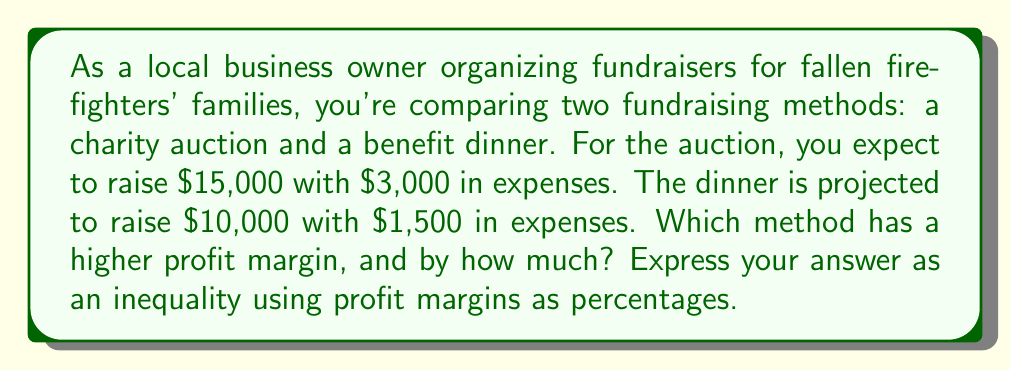Teach me how to tackle this problem. Let's solve this step-by-step:

1) First, let's calculate the profit margin for each method.

   Profit Margin = (Revenue - Expenses) / Revenue * 100%

2) For the charity auction:
   Revenue = $15,000
   Expenses = $3,000
   Profit Margin (Auction) = $(15000 - 3000) / 15000 * 100\%$
                           = $12000 / 15000 * 100\%$
                           = $0.8 * 100\%$ = $80\%$

3) For the benefit dinner:
   Revenue = $10,000
   Expenses = $1,500
   Profit Margin (Dinner) = $(10000 - 1500) / 10000 * 100\%$
                          = $8500 / 10000 * 100\%$
                          = $0.85 * 100\%$ = $85\%$

4) To compare, we can set up an inequality:

   Profit Margin (Dinner) > Profit Margin (Auction)
   $85\% > 80\%$

5) The difference is:
   $85\% - 80\% = 5\%$

Therefore, the benefit dinner has a higher profit margin by 5 percentage points.
Answer: $85\% > 80\%$, with a difference of $5\%$ 